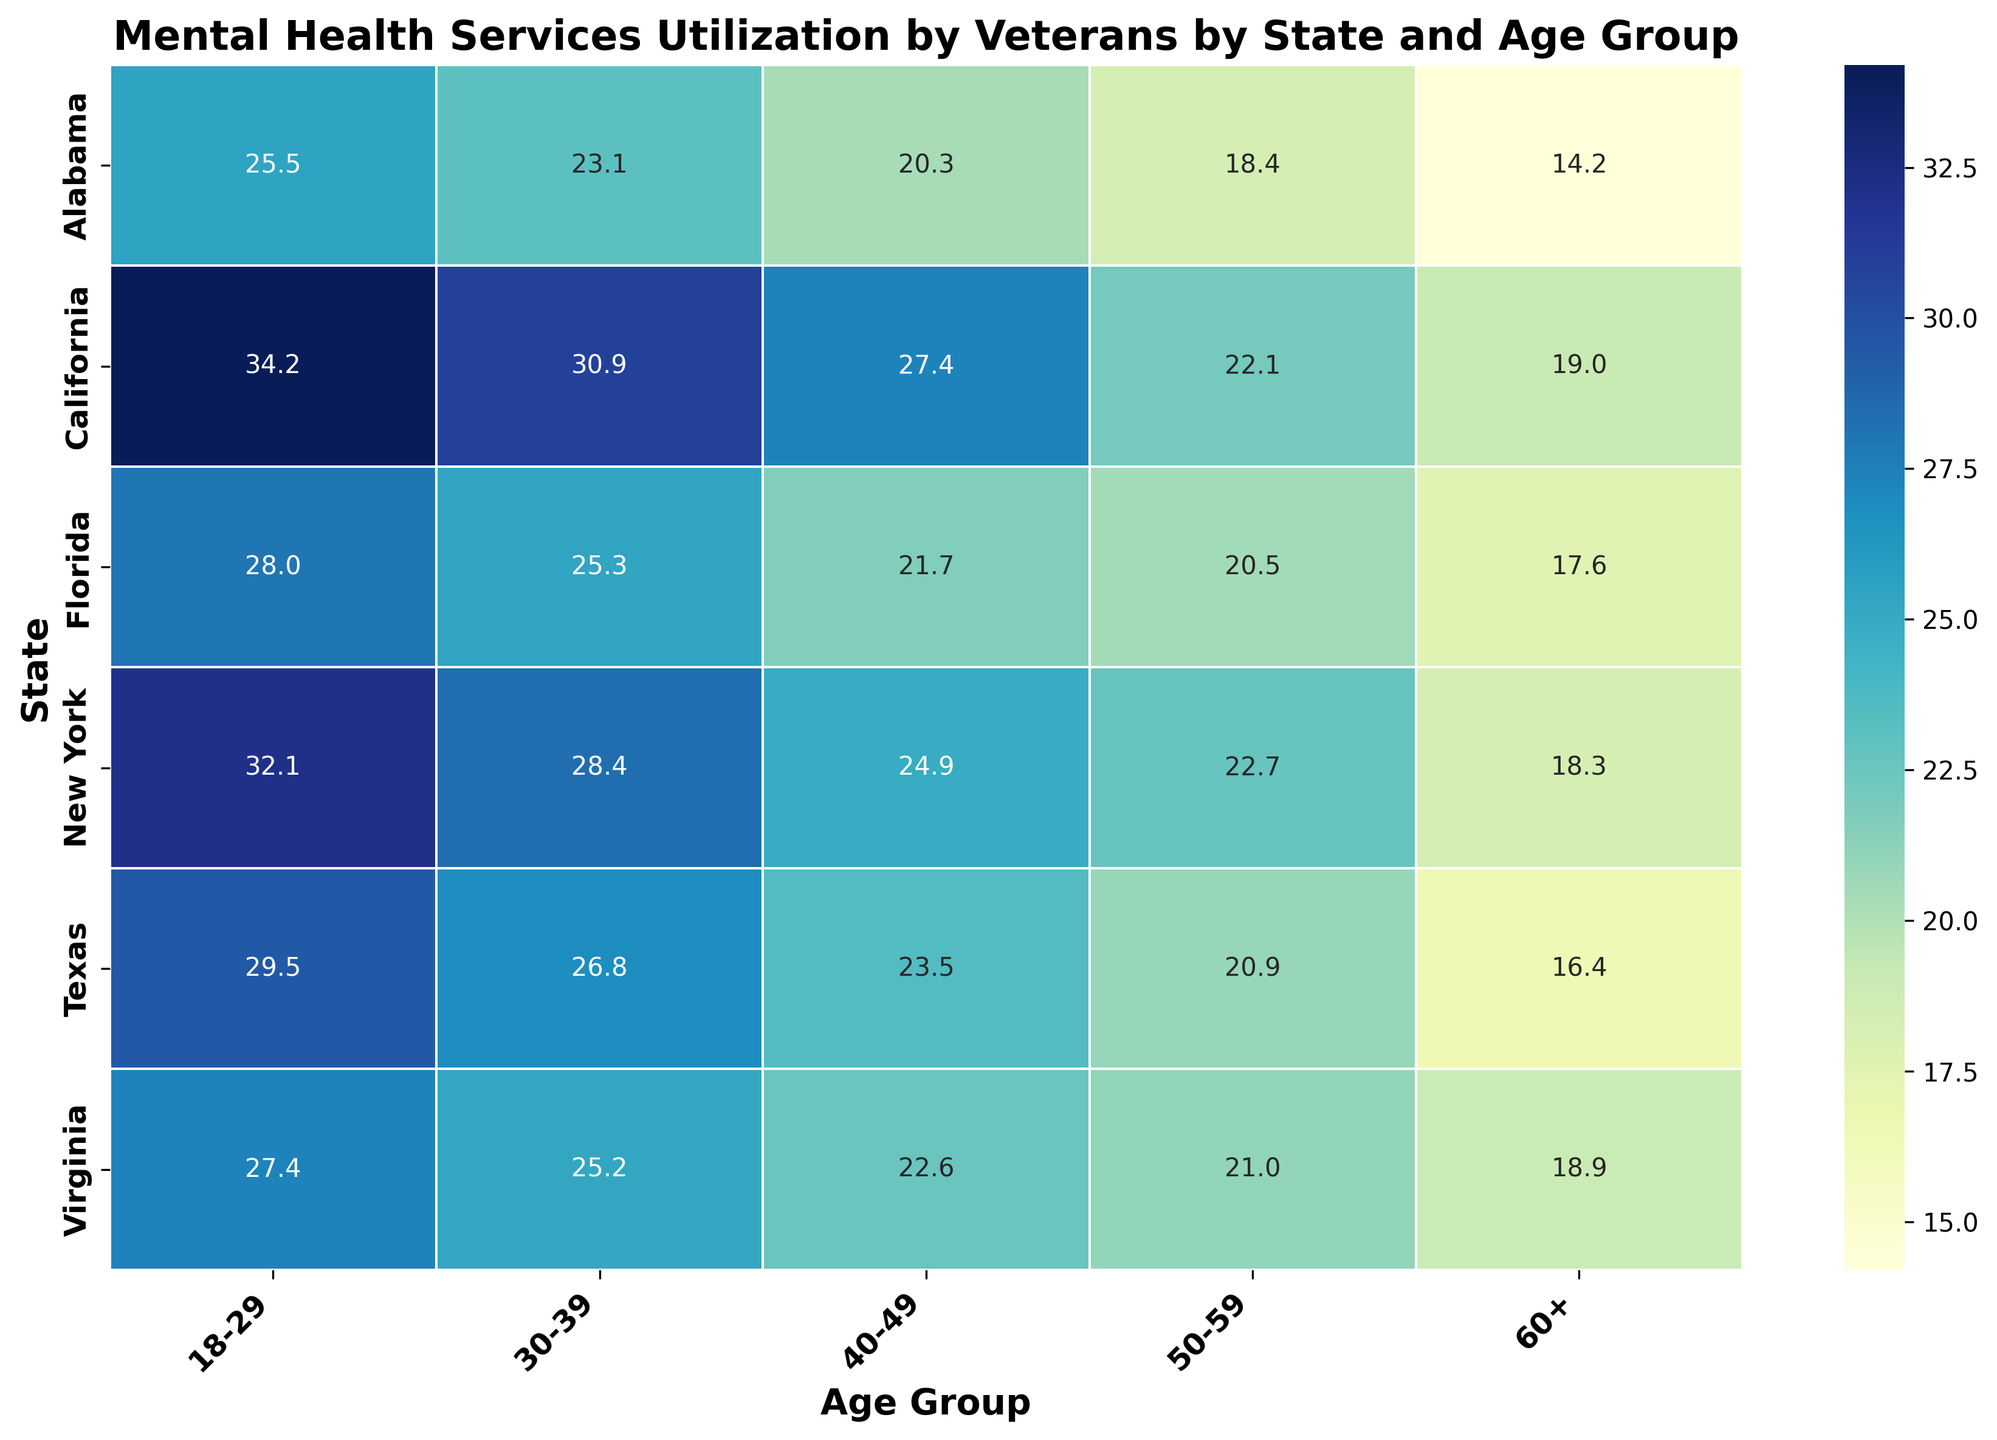Which state has the highest mental health services utilization for the 18-29 age group? By examining the heatmap, California has the darkest shade for the 18-29 age group, suggesting the highest utilization percentage.
Answer: California Which age group in New York utilizes mental health services the least? By observing New York's row and looking for the lightest shade, the 60+ age group has the lowest utilization percentage.
Answer: 60+ Compare the mental health services utilization between Virginia and Alabama for the 30-39 age group. Which state has a higher percentage? By comparing the shades of both states for the 30-39 age group, Virginia has a slightly darker color than Alabama, indicating a higher percentage.
Answer: Virginia What's the average utilization percentage for mental health services across all age groups in Florida? Add up the percentages for all age groups in Florida (28.0 + 25.3 + 21.7 + 20.5 + 17.6) and divide by the number of age groups (5).
Answer: 22.62% Which age group in Texas shows the minimum utilization of mental health services? By inspecting Texas' row and identifying the age group with the lightest shade, the 60+ age group shows the minimum utilization.
Answer: 60+ Determine the difference in utilization between the 18-29 age group in New York and the 50-59 age group in Alabama. Subtract the percentage for Alabama in the 50-59 age group (18.4) from the percentage for New York in the 18-29 age group (32.1).
Answer: 13.7% Between Florida and California, which state has a higher utilization rate for the 40-49 age group? By comparing the shades for the 40-49 age group, California has a darker shade than Florida, indicating a higher utilization rate.
Answer: California What is the cumulative mental health services utilization percentage for veterans aged 60+ across all states? Sum up the percentages for the 60+ age group across all states (14.2 + 19.0 + 17.6 + 18.3 + 16.4 + 18.9).
Answer: 104.4% Identify the state with the lowest mental health services utilization for the 30-39 age group. By scanning the heatmap and finding the lightest shade for the 30-39 age group row, Alabama has the lowest utilization.
Answer: Alabama How does the utilization rate for veterans aged 50-59 in Alabama compare with that in Texas? By comparing the shades and percentages for the 50-59 age group in Alabama (18.4) and Texas (20.9), Texas has a higher utilization rate.
Answer: Texas 